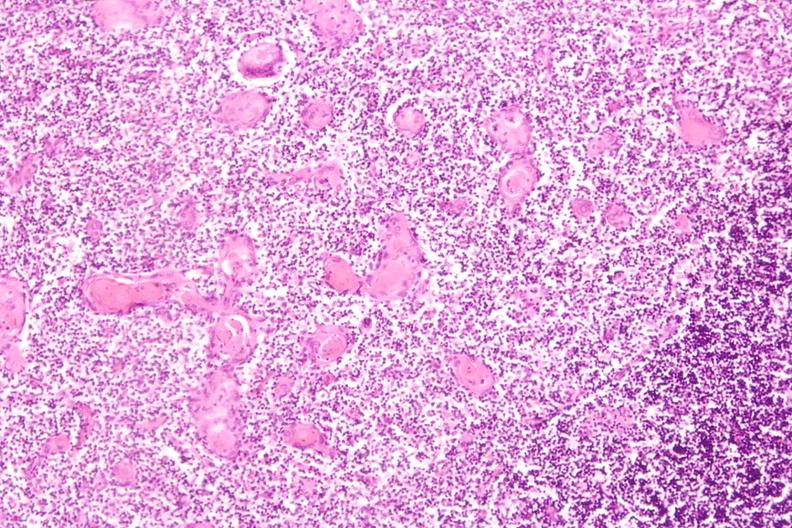does pituitary show thymus?
Answer the question using a single word or phrase. No 